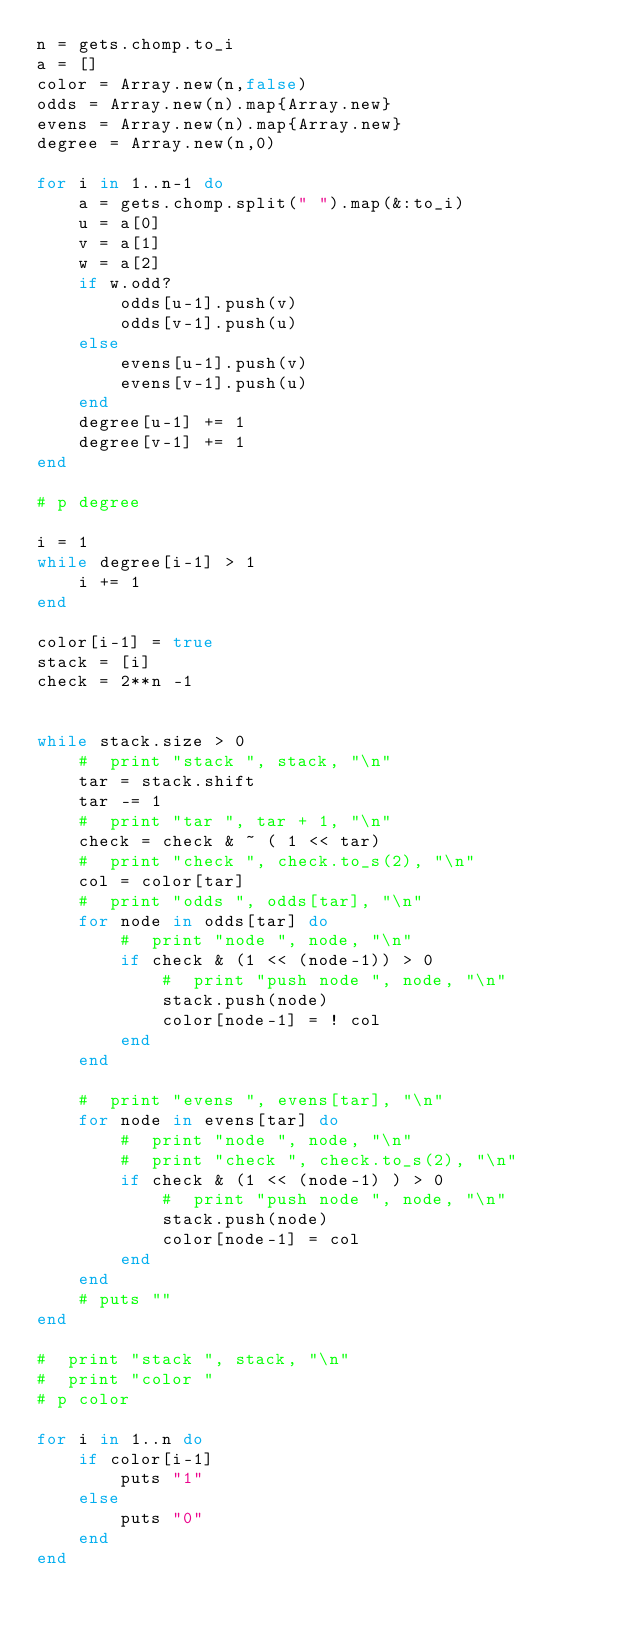<code> <loc_0><loc_0><loc_500><loc_500><_Ruby_>n = gets.chomp.to_i
a = []
color = Array.new(n,false)
odds = Array.new(n).map{Array.new}
evens = Array.new(n).map{Array.new}
degree = Array.new(n,0)

for i in 1..n-1 do
    a = gets.chomp.split(" ").map(&:to_i)
    u = a[0]
    v = a[1]
    w = a[2]
    if w.odd?
        odds[u-1].push(v)
        odds[v-1].push(u)
    else
        evens[u-1].push(v)
        evens[v-1].push(u)           
    end
    degree[u-1] += 1
    degree[v-1] += 1
end

# p degree

i = 1
while degree[i-1] > 1
    i += 1
end

color[i-1] = true
stack = [i]
check = 2**n -1


while stack.size > 0
    #  print "stack ", stack, "\n"
    tar = stack.shift
    tar -= 1
    #  print "tar ", tar + 1, "\n"
    check = check & ~ ( 1 << tar)
    #  print "check ", check.to_s(2), "\n"
    col = color[tar]
    #  print "odds ", odds[tar], "\n"
    for node in odds[tar] do
        #  print "node ", node, "\n"
        if check & (1 << (node-1)) > 0
            #  print "push node ", node, "\n"
            stack.push(node)
            color[node-1] = ! col
        end
    end 

    #  print "evens ", evens[tar], "\n"
    for node in evens[tar] do
        #  print "node ", node, "\n"
        #  print "check ", check.to_s(2), "\n"
        if check & (1 << (node-1) ) > 0
            #  print "push node ", node, "\n"
            stack.push(node)
            color[node-1] = col
        end
    end 
    # puts ""
end

#  print "stack ", stack, "\n"
#  print "color "
# p color

for i in 1..n do
    if color[i-1] 
        puts "1"
    else
        puts "0"
    end
end

</code> 